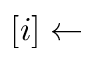Convert formula to latex. <formula><loc_0><loc_0><loc_500><loc_500>[ i ] \leftarrow</formula> 